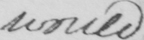Can you read and transcribe this handwriting? would 